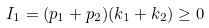<formula> <loc_0><loc_0><loc_500><loc_500>I _ { 1 } = ( p _ { 1 } + p _ { 2 } ) ( k _ { 1 } + k _ { 2 } ) \geq 0</formula> 